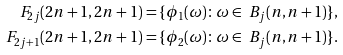<formula> <loc_0><loc_0><loc_500><loc_500>\ F _ { 2 j } ( 2 n + 1 , 2 n + 1 ) & = \{ \phi _ { 1 } ( \omega ) \colon \omega \in \ B _ { j } ( n , n + 1 ) \} , \\ \ F _ { 2 j + 1 } ( 2 n + 1 , 2 n + 1 ) & = \{ \phi _ { 2 } ( \omega ) \colon \omega \in \ B _ { j } ( n , n + 1 ) \} .</formula> 